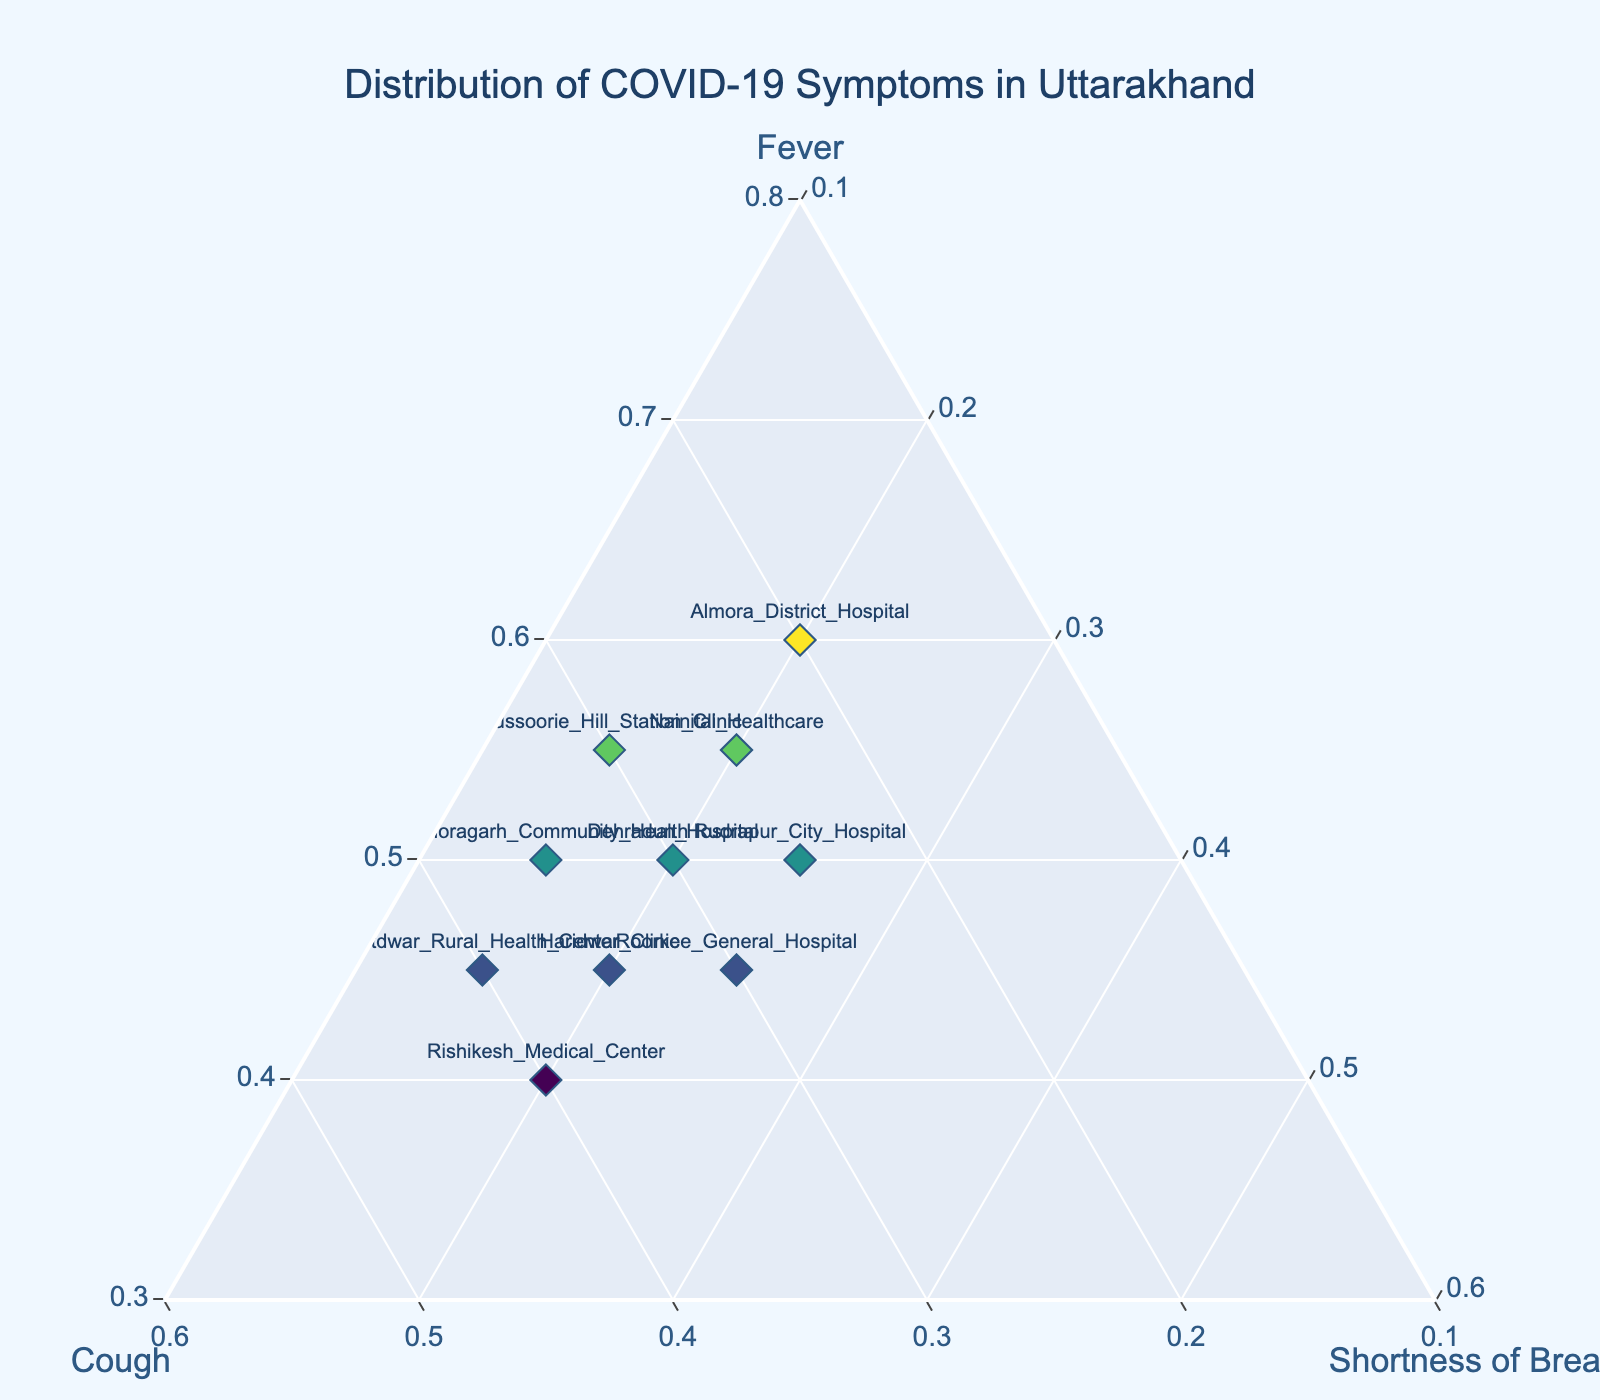What is the title of the ternary plot? The title of the plot is displayed at the top center of the figure and provides a brief description of what the plot represents.
Answer: Distribution of COVID-19 Symptoms in Uttarakhand How many healthcare centers are represented in the plot? Each marker on the ternary plot represents one healthcare center. Count the number of markers in the plot.
Answer: 10 Which healthcare center has the highest proportion of fever symptoms? Identify the marker that is closest to the 'Fever' axis's maximum value (i.e., highest 'a' value).
Answer: Almora_District_Hospital What are the proportions of symptoms observed for Rishikesh Medical Center? Locate the marker labeled 'Rishikesh_Medical_Center' and read off the proportions of 'Fever', 'Cough', and 'Shortness of Breath' from its position on the ternary plot.
Answer: Fever: 0.40, Cough: 0.40, Shortness of Breath: 0.20 Which two healthcare centers have the same proportion of shortness of breath symptoms? Look for two markers that are on the same level along the 'Shortness of Breath' axis.
Answer: Dehradun_Hospital and Haridwar_Clinic What is the average proportion of cough symptoms across all healthcare centers? Sum up all the proportions of cough symptoms from each healthcare center and divide by the total number of healthcare centers. Calculation: (0.30+0.35+0.25+0.40+0.20+0.30+0.35+0.30+0.25+0.40)/10
Answer: 0.31 Which region has the highest combined proportion of fever and shortness of breath symptoms? Calculate the sum of 'Fever' and 'Shortness_of_Breath' for each region and find the highest value.
Answer: Almora_District_Hospital (0.60 + 0.20 = 0.80) How do the symptom distributions for Nainital Healthcare and Rudrapur City Hospital compare? Compare the values of 'Fever', 'Cough', and 'Shortness of Breath' for both healthcare centers.
Answer: Nainital: 0.55, 0.25, 0.20; Rudrapur: 0.50, 0.25, 0.25 Which healthcare center has the lowest proportion of fever symptoms? Identify the marker that is closest to the 'Cough' and 'Shortness of Breath' axes, indicating a low 'Fever' proportion.
Answer: Rishikesh_Medical_Center Is there any healthcare center where the proportion of cough symptoms exceeds fever symptoms? If yes, name it. Check each healthcare center's marker to see if the proportion of 'Cough' is greater than 'Fever'.
Answer: Rishikesh_Medical_Center 